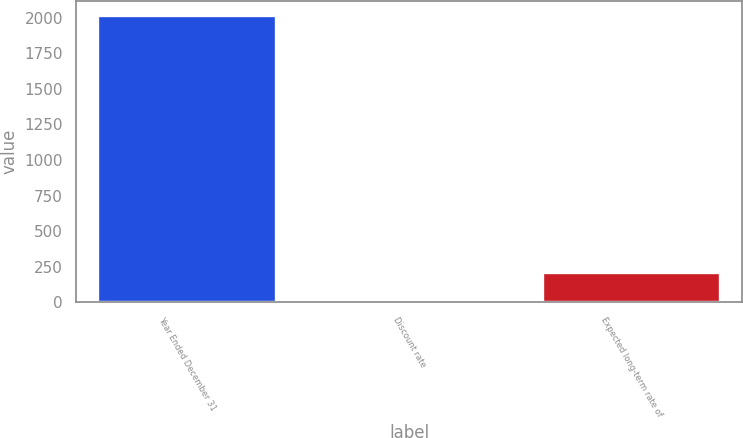<chart> <loc_0><loc_0><loc_500><loc_500><bar_chart><fcel>Year Ended December 31<fcel>Discount rate<fcel>Expected long-term rate of<nl><fcel>2015<fcel>3.75<fcel>204.88<nl></chart> 